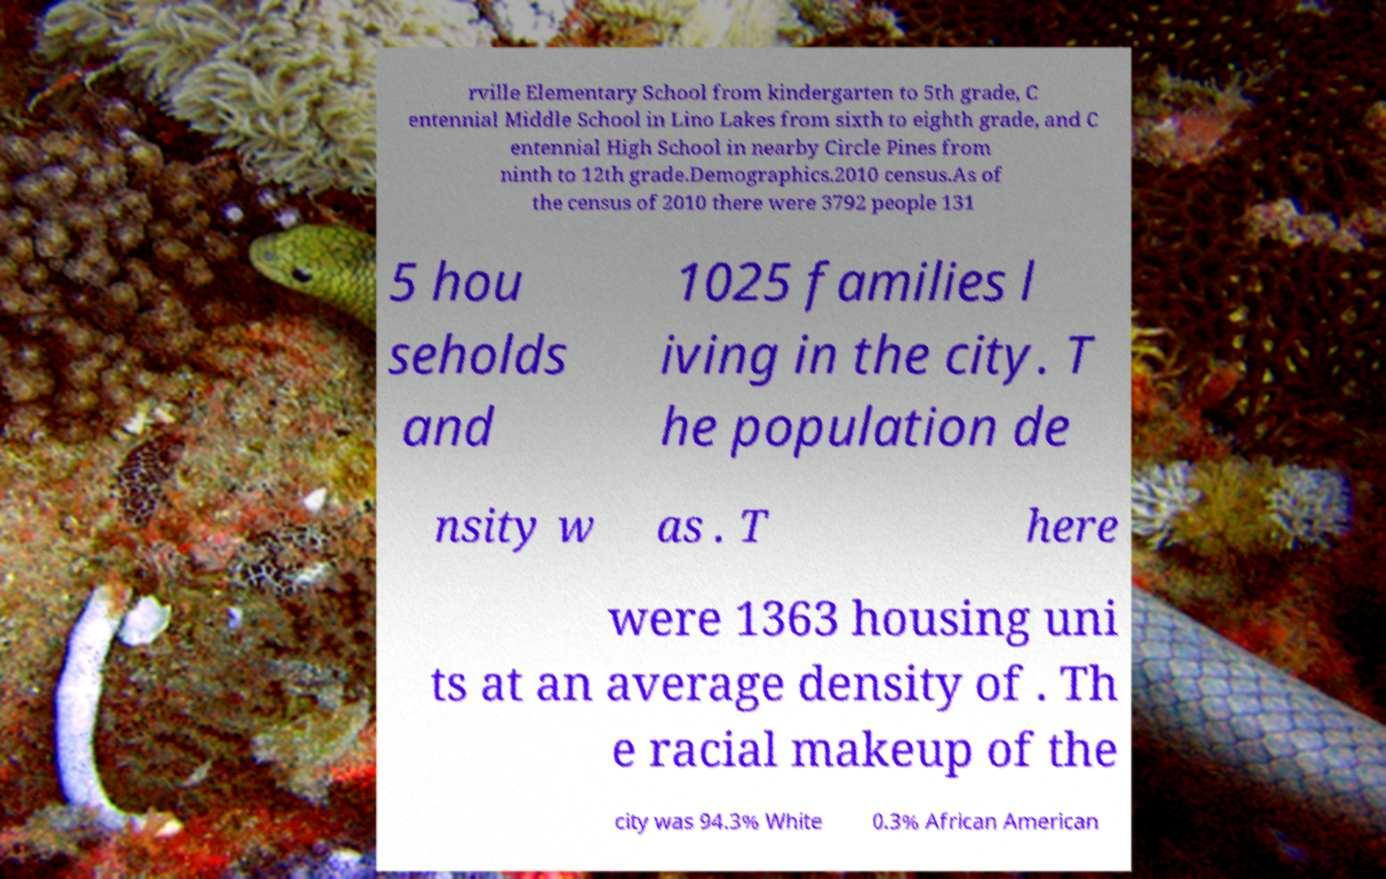For documentation purposes, I need the text within this image transcribed. Could you provide that? rville Elementary School from kindergarten to 5th grade, C entennial Middle School in Lino Lakes from sixth to eighth grade, and C entennial High School in nearby Circle Pines from ninth to 12th grade.Demographics.2010 census.As of the census of 2010 there were 3792 people 131 5 hou seholds and 1025 families l iving in the city. T he population de nsity w as . T here were 1363 housing uni ts at an average density of . Th e racial makeup of the city was 94.3% White 0.3% African American 